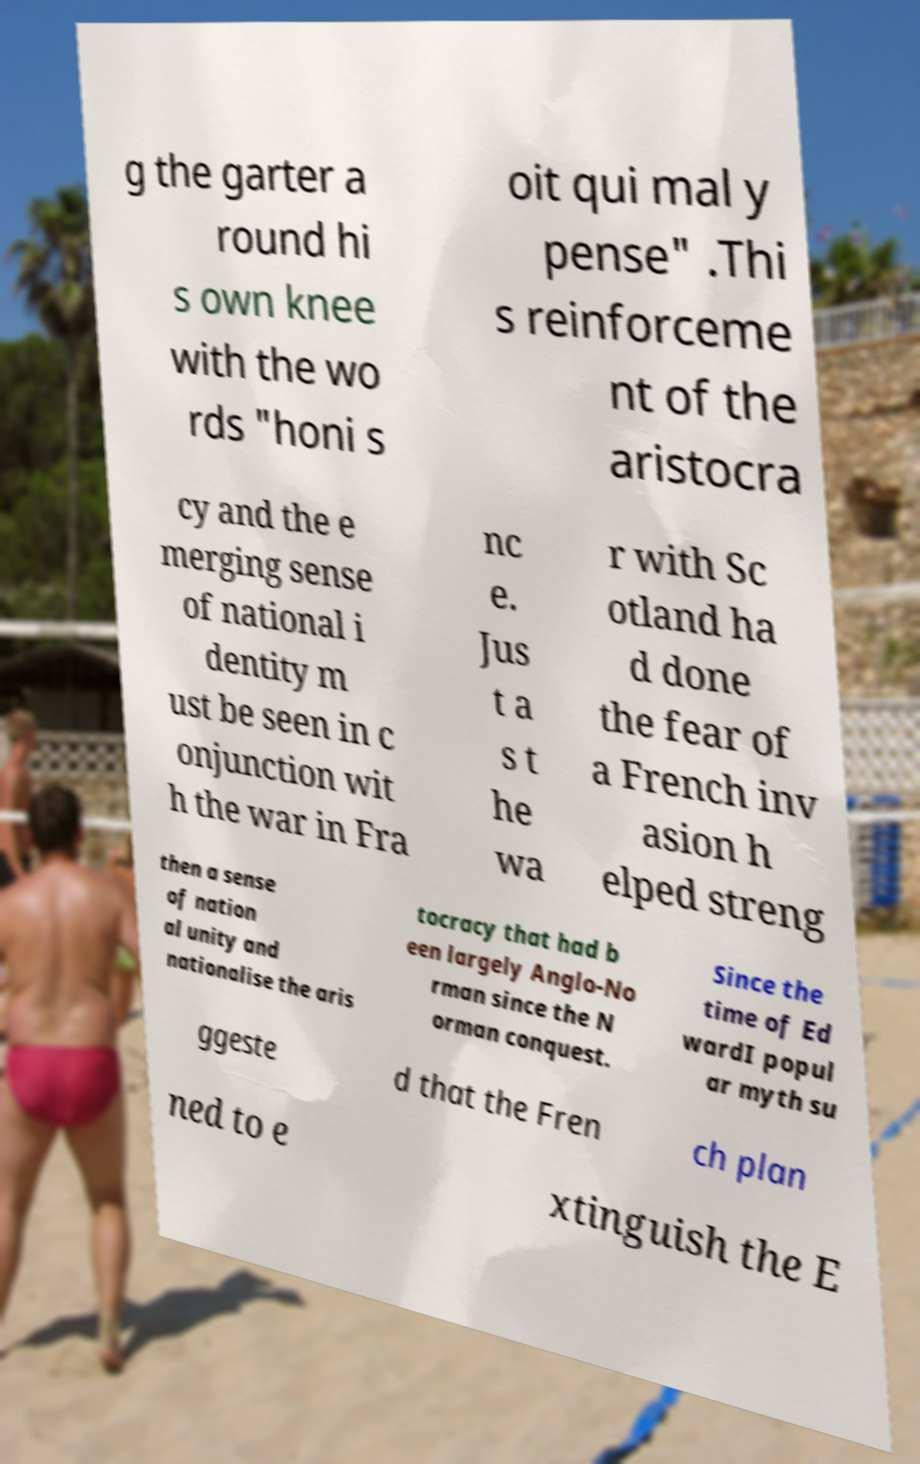I need the written content from this picture converted into text. Can you do that? g the garter a round hi s own knee with the wo rds "honi s oit qui mal y pense" .Thi s reinforceme nt of the aristocra cy and the e merging sense of national i dentity m ust be seen in c onjunction wit h the war in Fra nc e. Jus t a s t he wa r with Sc otland ha d done the fear of a French inv asion h elped streng then a sense of nation al unity and nationalise the aris tocracy that had b een largely Anglo-No rman since the N orman conquest. Since the time of Ed wardI popul ar myth su ggeste d that the Fren ch plan ned to e xtinguish the E 